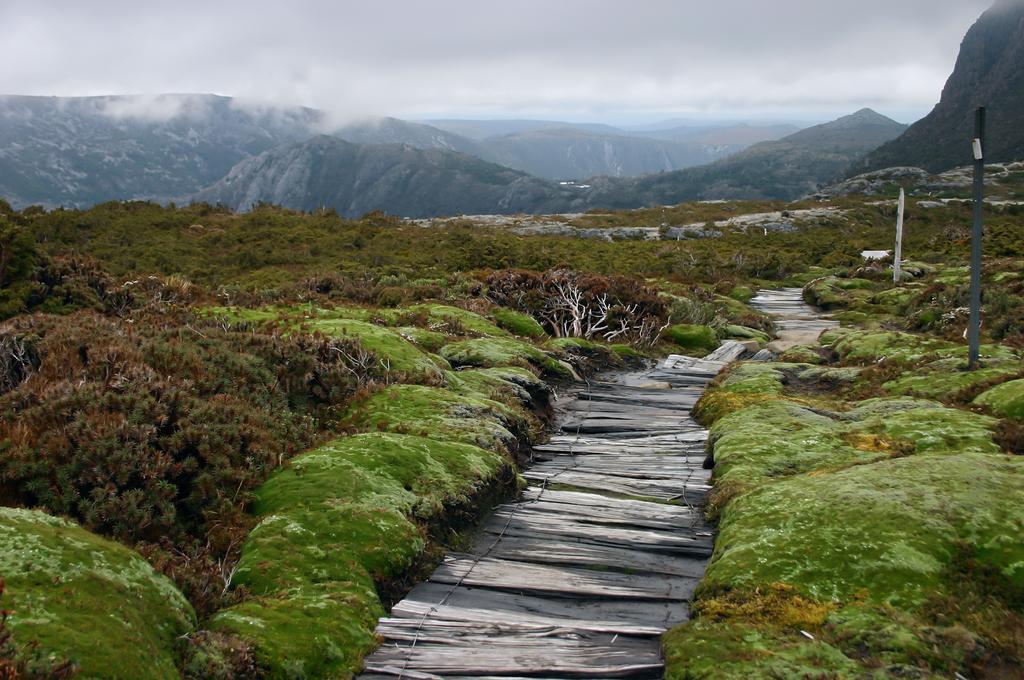In one or two sentences, can you explain what this image depicts? In this image there are wooden steps in the middle. There are small plants on either side of it. In the background there are so many mountains. At the top there is the sky. On the right side there are two poles. 